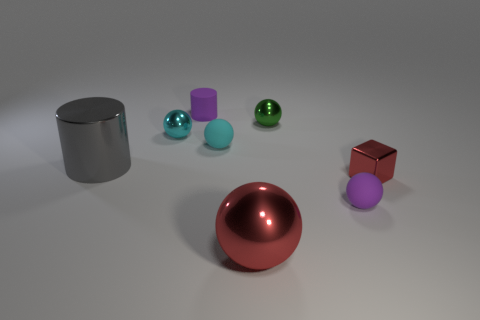Do the shiny block and the large shiny ball have the same color?
Your answer should be very brief. Yes. What is the shape of the purple thing in front of the large gray metallic object?
Ensure brevity in your answer.  Sphere. What is the color of the matte thing in front of the object on the right side of the small matte object to the right of the big red thing?
Keep it short and to the point. Purple. What shape is the cyan object that is made of the same material as the tiny purple cylinder?
Provide a short and direct response. Sphere. Is the number of purple shiny things less than the number of small metallic objects?
Keep it short and to the point. Yes. Do the red block and the purple sphere have the same material?
Your answer should be very brief. No. How many other things are there of the same color as the small matte cylinder?
Your answer should be very brief. 1. Is the number of small matte cylinders greater than the number of metallic spheres?
Provide a succinct answer. No. There is a shiny cube; is its size the same as the purple matte thing in front of the red block?
Provide a succinct answer. Yes. There is a matte sphere left of the small purple matte sphere; what is its color?
Your answer should be compact. Cyan. 